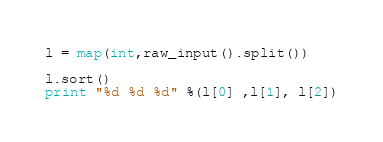Convert code to text. <code><loc_0><loc_0><loc_500><loc_500><_Python_>l = map(int,raw_input().split())

l.sort()
print "%d %d %d" %(l[0] ,l[1], l[2])</code> 